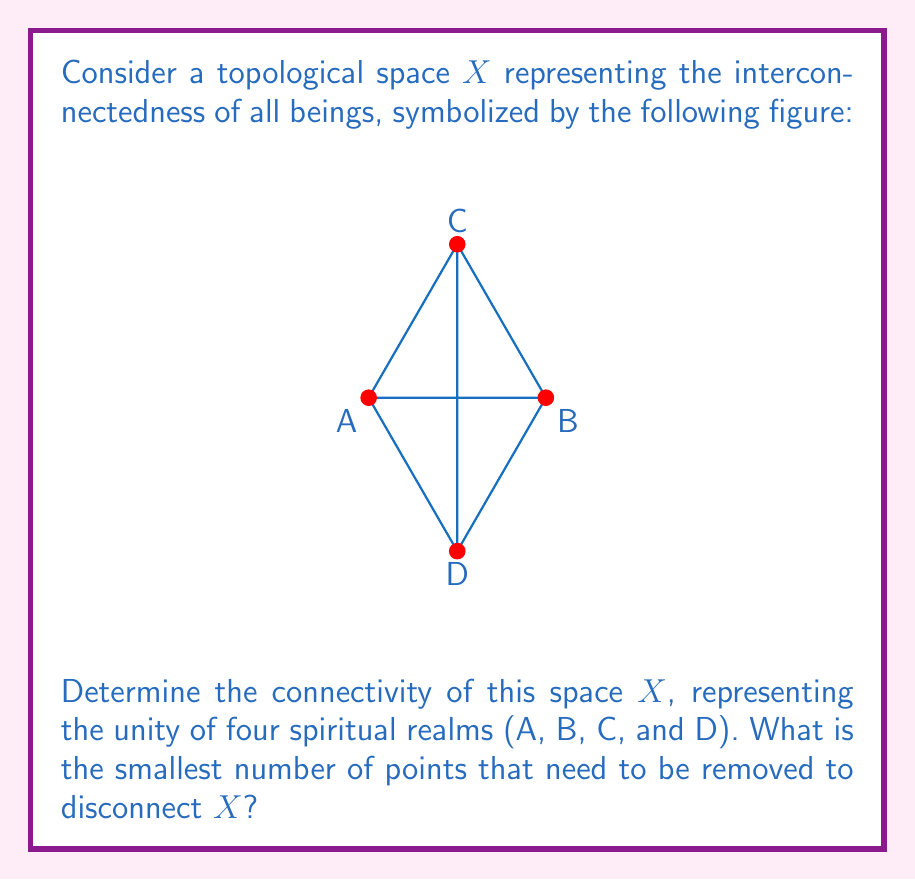Give your solution to this math problem. To determine the connectivity of the topological space $X$, we need to analyze its structure and properties:

1) The space $X$ is represented by a complete graph $K_4$ with four vertices (A, B, C, and D) and six edges connecting every pair of vertices.

2) In topological terms, we're looking for the vertex connectivity of this graph, which is the minimum number of vertices that need to be removed to disconnect the graph.

3) For a complete graph $K_n$, the vertex connectivity is always $n-1$, where $n$ is the number of vertices.

4) In this case, $n = 4$, so the vertex connectivity is $4 - 1 = 3$.

5) This means that removing any two vertices will still leave the graph connected, but removing three vertices will disconnect it.

6) Intuitively, this represents the strong interconnectedness of the four spiritual realms. The unity is so strong that even if two realms are removed, the remaining two will still be connected.

7) In terms of spiritual interpretation, this high connectivity symbolizes the robust and resilient nature of universal interconnectedness, where the bond between realms remains strong even in the face of significant disruptions.
Answer: 3 